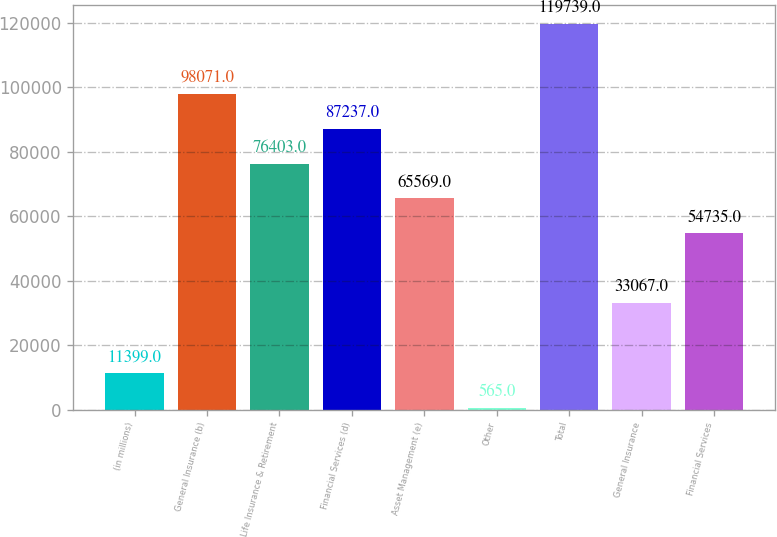Convert chart. <chart><loc_0><loc_0><loc_500><loc_500><bar_chart><fcel>(in millions)<fcel>General Insurance (b)<fcel>Life Insurance & Retirement<fcel>Financial Services (d)<fcel>Asset Management (e)<fcel>Other<fcel>Total<fcel>General Insurance<fcel>Financial Services<nl><fcel>11399<fcel>98071<fcel>76403<fcel>87237<fcel>65569<fcel>565<fcel>119739<fcel>33067<fcel>54735<nl></chart> 